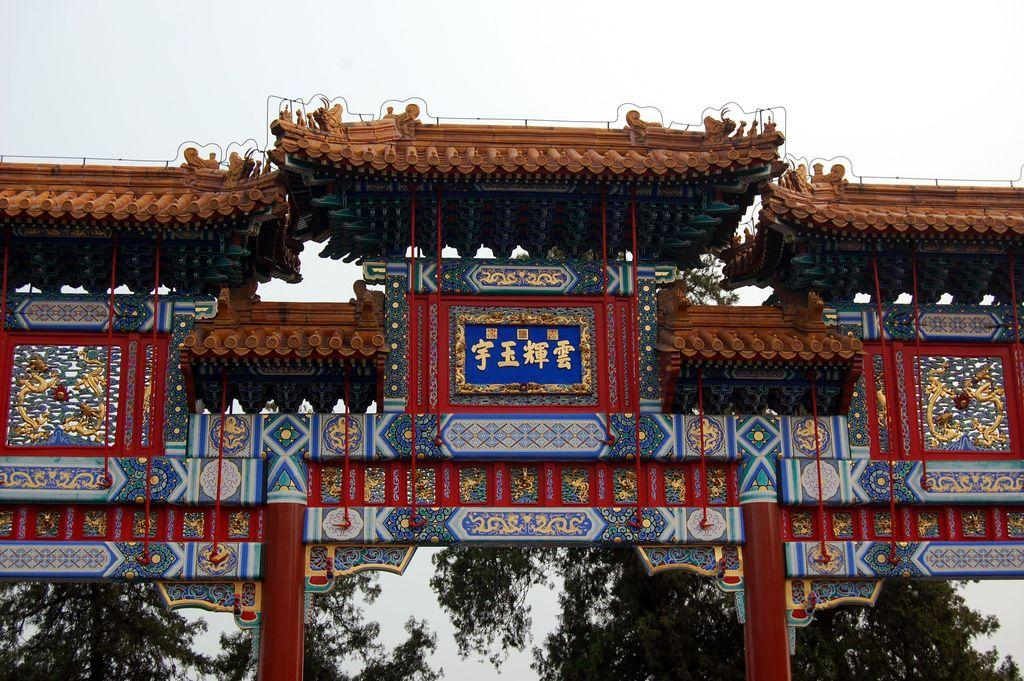What structure is present in the image? There is an arch in the image. What can you tell about the appearance of the arch? The arch has multiple colors. What can be seen in the background of the image? There are trees in the background of the image. What is the color of the sky in the image? The sky is white in color. How many rooms can be seen in the image? There are no rooms visible in the image; it features an arch, trees in the background, and a white sky. 